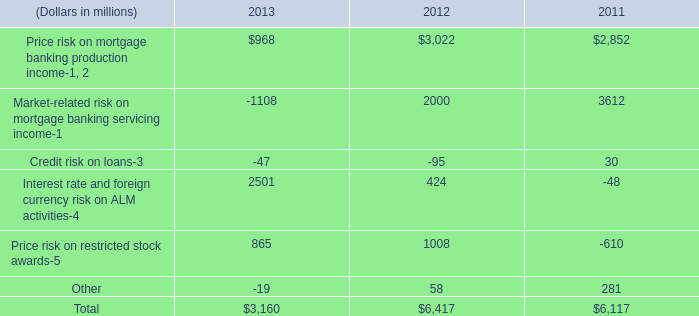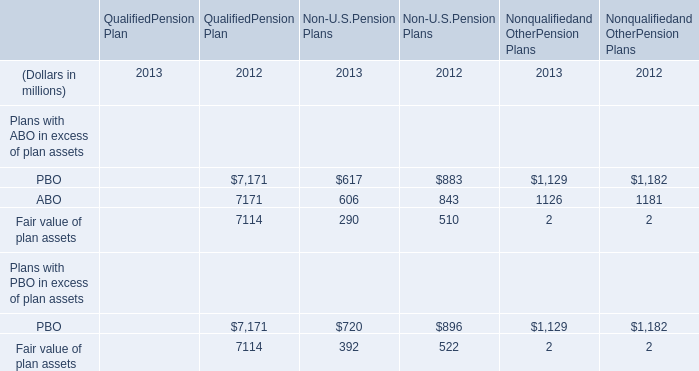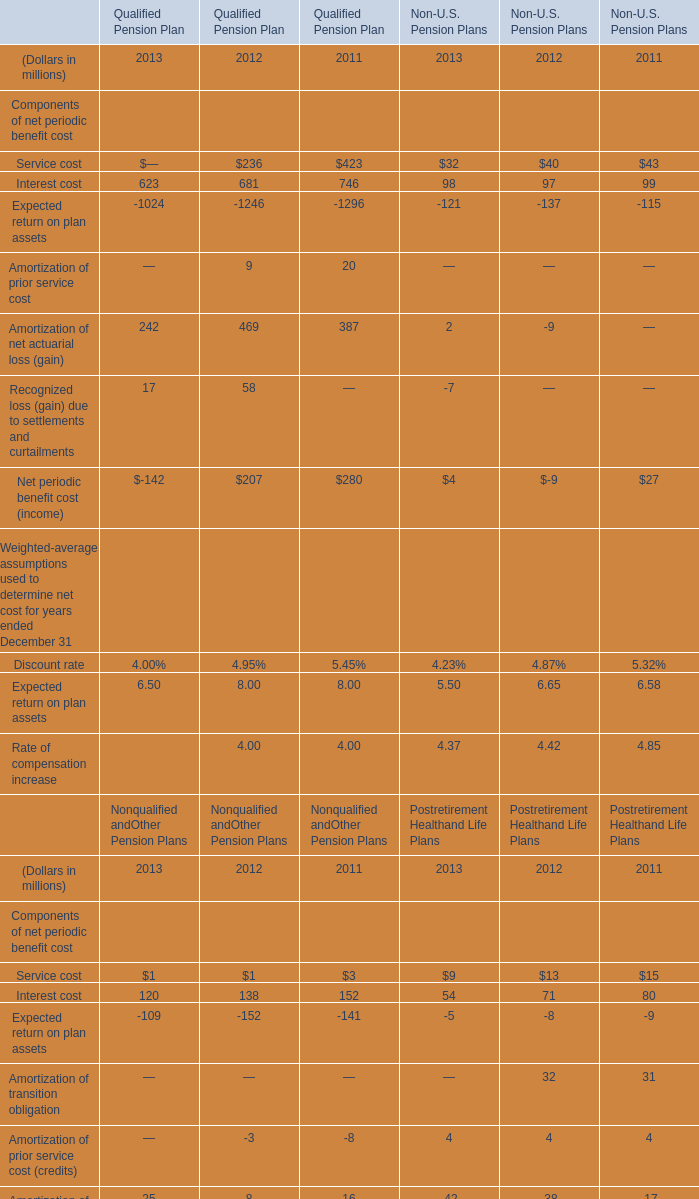What's the average of PBO and ABO of Non-U.S.Pension Plans in 2013? (in millions) 
Computations: ((617 + 606) / 2)
Answer: 611.5. 